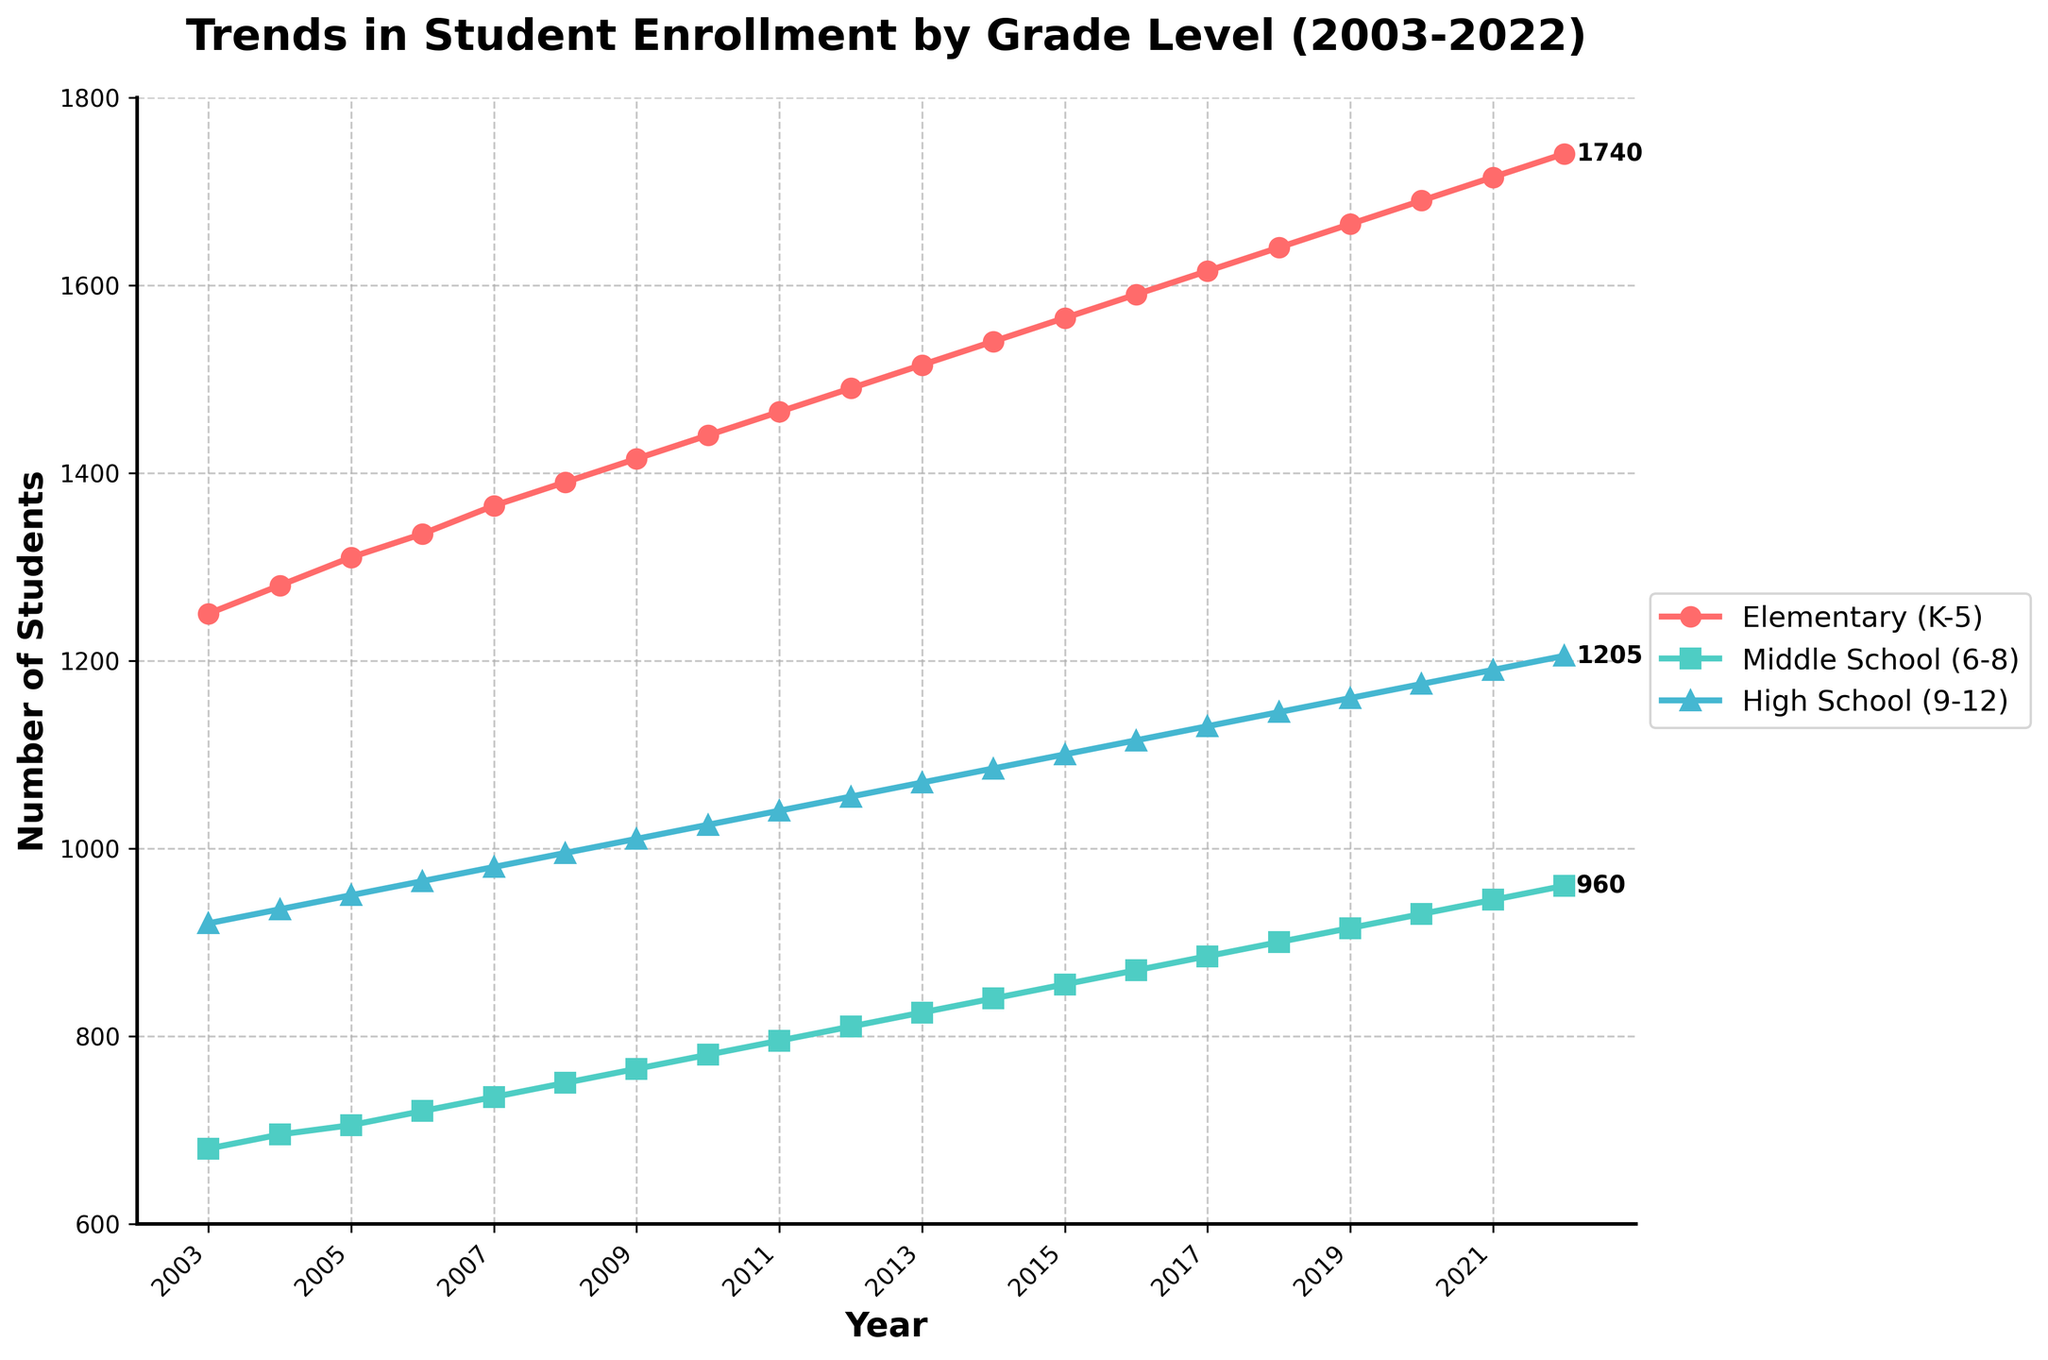What is the overall trend in student enrollment at elementary schools from 2003 to 2022? From the line corresponding to elementary schools, we see an upward trend. In 2003, the enrollment was 1250 students, and it increased to 1740 students by 2022. This indicates a steady increase over the 20-year period.
Answer: Steady increase How does the enrollment growth in middle schools from 2003 to 2022 compare with high schools over the same period? To compare the growth, we need to calculate the difference between the enrollment in 2022 and 2003 for both categories. For middle schools, the enrollment increased from 680 to 960 (difference of 280). For high schools, it increased from 920 to 1205 (difference of 285). The growth in both school levels is quite similar, but slightly higher in high schools.
Answer: Similar growth, slightly higher in high schools Which grade level had the highest number of students enrolled in 2015, and by how much more compared to the other two grades? In 2015, we find by looking at the markers that Elementary (1565) had the highest enrollment. Middle School had 855 students and High School had 1100 students. Elementary had 465 more students than Middle School (1565-855) and 465 more than High School (1565-1100).
Answer: Elementary (465 more than both) What was the rate of increase in elementary school enrollment from 2010 to 2020? The enrollment in elementary schools in 2010 was 1440 students and in 2020, it was 1690 students. The increase is 1690 - 1440 = 250 students over 10 years. The rate of increase per year is 250 students / 10 years = 25 students per year.
Answer: 25 students per year During which year did middle schools see an enrollment number that is exactly halfway between its 2003 and 2022 figures? In 2003, middle school enrollment was 680 and in 2022 it was 960. Halfway between these numbers is (680 + 960) / 2 = 820. Checking the data, middle school enrollment was 820 in 2013.
Answer: 2013 Which grade level experienced the least total increase in student enrollment from 2003 to 2022? To determine the least increase, we calculate the differences: - Elementary: 1740 - 1250 = 490 - Middle School: 960 - 680 = 280 - High School: 1205 - 920 = 285 Middle School experienced the least increase in student enrollment.
Answer: Middle School In which years did high school enrollments surpass 1000 students? By looking at the plot points for high schools, high school enrollment surpassed 1000 students starting in 2009 and onwards.
Answer: From 2009 onwards What can be inferred about the consistency of enrollment trends across the three grade levels? All three grade levels show a consistent upward trend in enrollment over the years without any sudden dips, indicating steady growth in student population across all school levels.
Answer: Consistent upward trend How much higher is elementary school enrollment compared to middle school enrollment in 2022? In 2022, elementary school enrollment was 1740 and middle school enrollment was 960. The difference is 1740 - 960 = 780 students.
Answer: 780 students 